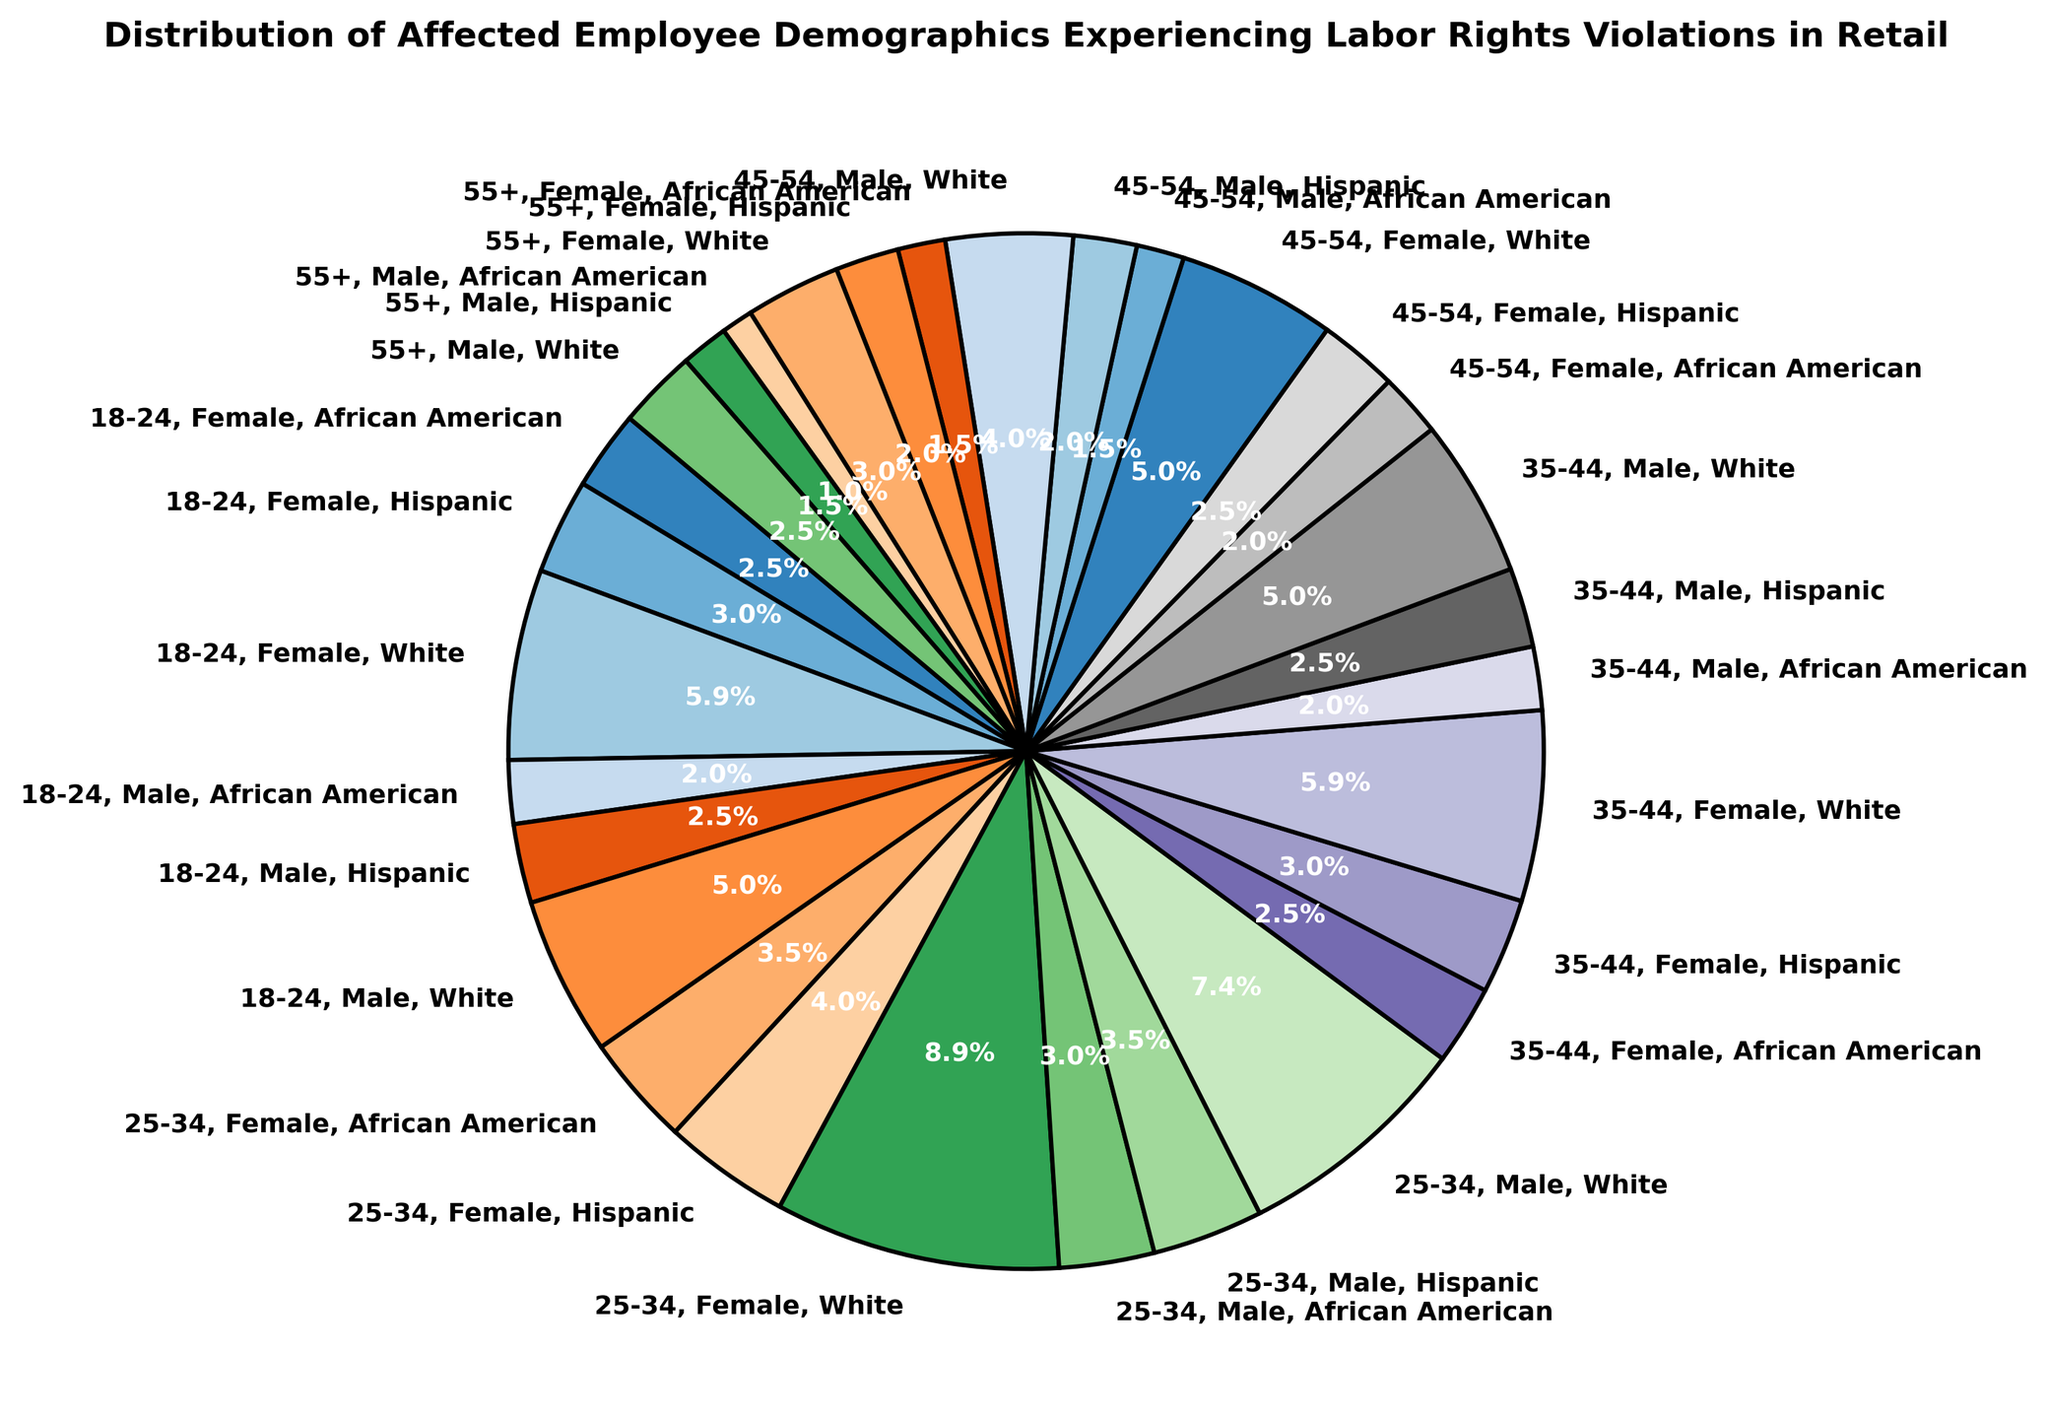Which age group has the highest percentage of employees experiencing labor rights violations? To determine the age group with the highest percentage, we examine the pie chart and identify the largest segment. The ‘25-34’ age group appears to have the largest portion.
Answer: 25-34 What is the combined percentage of female Hispanic employees across all age groups? We need to find and add the percentage of female Hispanic employees in each age group from the pie chart: 6% (18-24) + 8% (25-34) + 6% (35-44) + 5% (45-54) + 4% (55+). Summing up these percentages yields the total.
Answer: 29% Compare the percentage of male and female White employees in the 35-44 age group. Which gender has a higher percentage? By examining the pie chart, we find the segments for male and female White employees in the 35-44 age group: 10% for males and 12% for females. Clearly, the female percentage is higher.
Answer: Female What is the total percentage of African American employees experiencing labor rights violations? To get the total percentage of African American employees, sum up the percentages across all age groups: 4% + 5% + 6% + 7% (18-34) + 4% + 5% (35-44) + 3% + 4% (45-54) + 2% + 3% (55+). Adding these up gives the total.
Answer: 43% Which demographic group (age group, gender, ethnicity) has the lowest percentage of labor rights violations? We identify the smallest segment in the pie chart. The segment for '55+, Male, African American' with 2% is the smallest.
Answer: 55+, Male, African American 